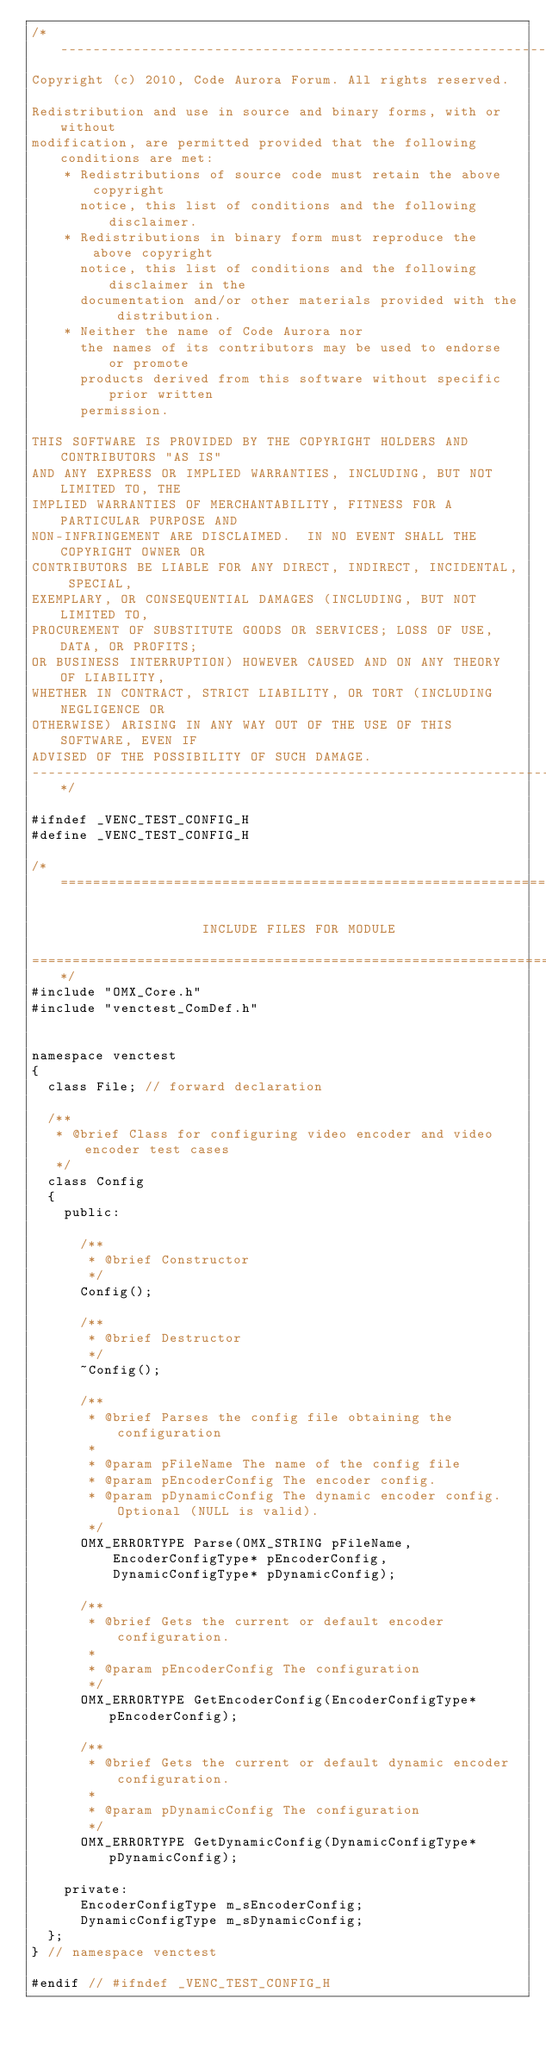Convert code to text. <code><loc_0><loc_0><loc_500><loc_500><_C_>/*--------------------------------------------------------------------------
Copyright (c) 2010, Code Aurora Forum. All rights reserved.

Redistribution and use in source and binary forms, with or without
modification, are permitted provided that the following conditions are met:
    * Redistributions of source code must retain the above copyright
      notice, this list of conditions and the following disclaimer.
    * Redistributions in binary form must reproduce the above copyright
      notice, this list of conditions and the following disclaimer in the
      documentation and/or other materials provided with the distribution.
    * Neither the name of Code Aurora nor
      the names of its contributors may be used to endorse or promote
      products derived from this software without specific prior written
      permission.

THIS SOFTWARE IS PROVIDED BY THE COPYRIGHT HOLDERS AND CONTRIBUTORS "AS IS"
AND ANY EXPRESS OR IMPLIED WARRANTIES, INCLUDING, BUT NOT LIMITED TO, THE
IMPLIED WARRANTIES OF MERCHANTABILITY, FITNESS FOR A PARTICULAR PURPOSE AND
NON-INFRINGEMENT ARE DISCLAIMED.  IN NO EVENT SHALL THE COPYRIGHT OWNER OR
CONTRIBUTORS BE LIABLE FOR ANY DIRECT, INDIRECT, INCIDENTAL, SPECIAL,
EXEMPLARY, OR CONSEQUENTIAL DAMAGES (INCLUDING, BUT NOT LIMITED TO,
PROCUREMENT OF SUBSTITUTE GOODS OR SERVICES; LOSS OF USE, DATA, OR PROFITS;
OR BUSINESS INTERRUPTION) HOWEVER CAUSED AND ON ANY THEORY OF LIABILITY,
WHETHER IN CONTRACT, STRICT LIABILITY, OR TORT (INCLUDING NEGLIGENCE OR
OTHERWISE) ARISING IN ANY WAY OUT OF THE USE OF THIS SOFTWARE, EVEN IF
ADVISED OF THE POSSIBILITY OF SUCH DAMAGE.
--------------------------------------------------------------------------*/

#ifndef _VENC_TEST_CONFIG_H
#define _VENC_TEST_CONFIG_H

/*========================================================================

                     INCLUDE FILES FOR MODULE

==========================================================================*/
#include "OMX_Core.h"
#include "venctest_ComDef.h"


namespace venctest
{
  class File; // forward declaration

  /**
   * @brief Class for configuring video encoder and video encoder test cases
   */
  class Config
  {
    public:

      /**
       * @brief Constructor
       */
      Config();

      /**
       * @brief Destructor
       */
      ~Config();

      /**
       * @brief Parses the config file obtaining the configuration
       *
       * @param pFileName The name of the config file
       * @param pEncoderConfig The encoder config.
       * @param pDynamicConfig The dynamic encoder config. Optional (NULL is valid).
       */
      OMX_ERRORTYPE Parse(OMX_STRING pFileName,
          EncoderConfigType* pEncoderConfig,
          DynamicConfigType* pDynamicConfig);

      /**
       * @brief Gets the current or default encoder configuration.
       *
       * @param pEncoderConfig The configuration
       */
      OMX_ERRORTYPE GetEncoderConfig(EncoderConfigType* pEncoderConfig);

      /**
       * @brief Gets the current or default dynamic encoder configuration.
       *
       * @param pDynamicConfig The configuration
       */
      OMX_ERRORTYPE GetDynamicConfig(DynamicConfigType* pDynamicConfig);

    private:
      EncoderConfigType m_sEncoderConfig;
      DynamicConfigType m_sDynamicConfig;
  };
} // namespace venctest

#endif // #ifndef _VENC_TEST_CONFIG_H
</code> 